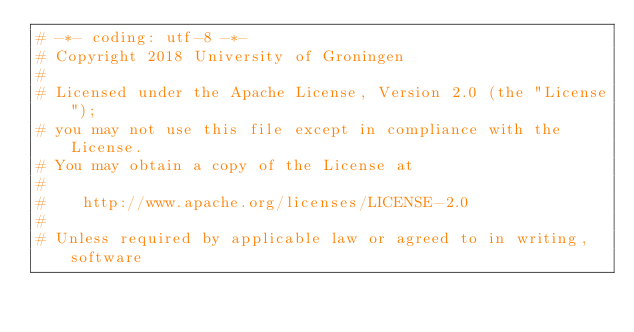Convert code to text. <code><loc_0><loc_0><loc_500><loc_500><_Python_># -*- coding: utf-8 -*-
# Copyright 2018 University of Groningen
#
# Licensed under the Apache License, Version 2.0 (the "License");
# you may not use this file except in compliance with the License.
# You may obtain a copy of the License at
#
#    http://www.apache.org/licenses/LICENSE-2.0
#
# Unless required by applicable law or agreed to in writing, software</code> 